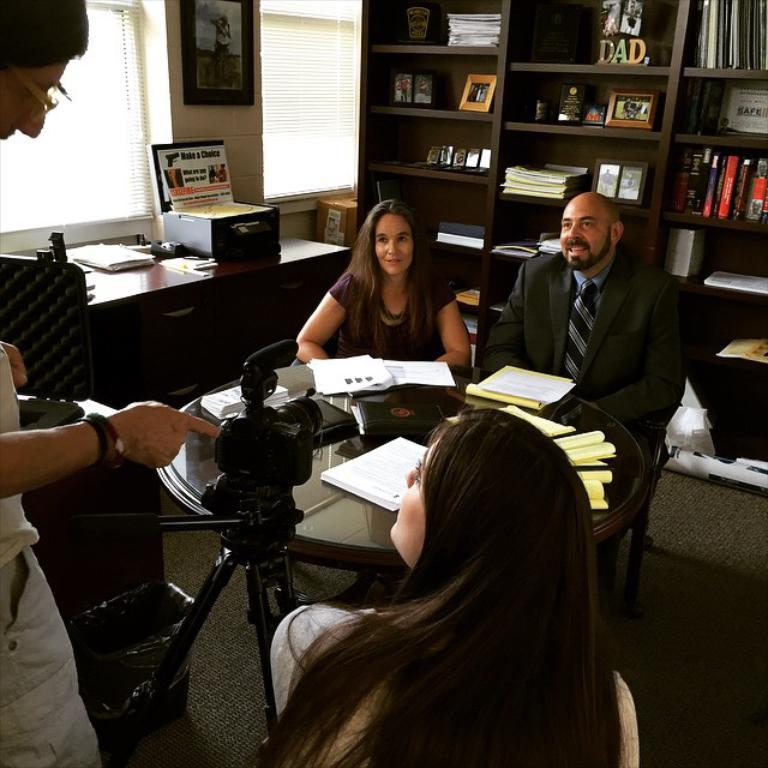<image>
Share a concise interpretation of the image provided. A group of people meet at a table with a sign that says "Make a Choice" in the background. 